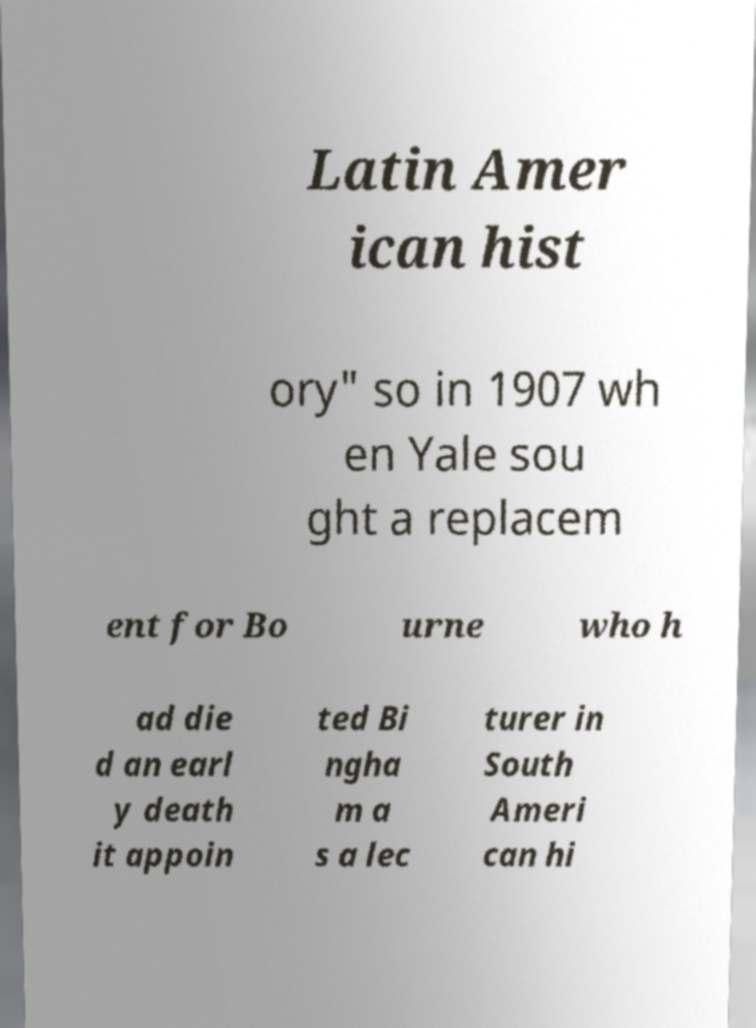I need the written content from this picture converted into text. Can you do that? Latin Amer ican hist ory" so in 1907 wh en Yale sou ght a replacem ent for Bo urne who h ad die d an earl y death it appoin ted Bi ngha m a s a lec turer in South Ameri can hi 